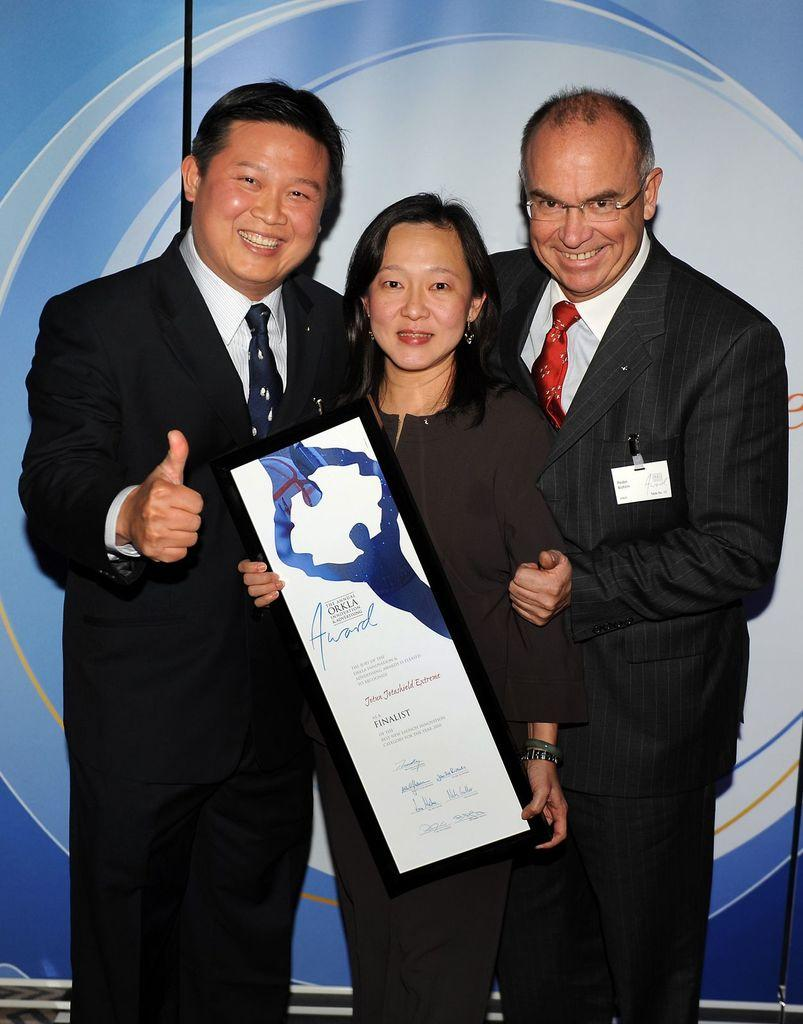How many people are on the stage in the image? There are three people standing on the stage. What is the center person holding? The center person is holding an award. What can be seen at the back side of the stage? There is a banner at the back side of the stage. What type of copper material is used to make the giraffe visible in the image? There is no giraffe or copper material present in the image. How many snakes are slithering around the people on the stage? There are no snakes visible in the image; it features three people standing on the stage. 